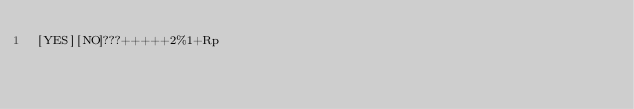Convert code to text. <code><loc_0><loc_0><loc_500><loc_500><_dc_>[YES][NO]???+++++2%1+Rp</code> 